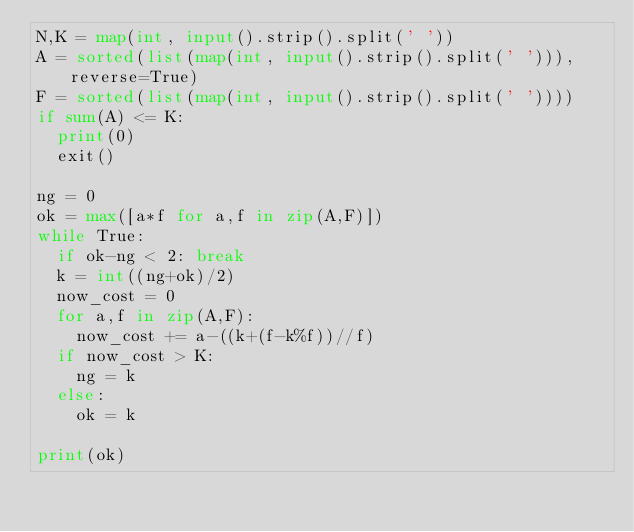Convert code to text. <code><loc_0><loc_0><loc_500><loc_500><_Python_>N,K = map(int, input().strip().split(' '))
A = sorted(list(map(int, input().strip().split(' '))), reverse=True)
F = sorted(list(map(int, input().strip().split(' '))))
if sum(A) <= K:
  print(0)
  exit()

ng = 0
ok = max([a*f for a,f in zip(A,F)])
while True:
  if ok-ng < 2: break
  k = int((ng+ok)/2)
  now_cost = 0
  for a,f in zip(A,F):
    now_cost += a-((k+(f-k%f))//f)
  if now_cost > K:
    ng = k
  else:
    ok = k
    
print(ok)
</code> 